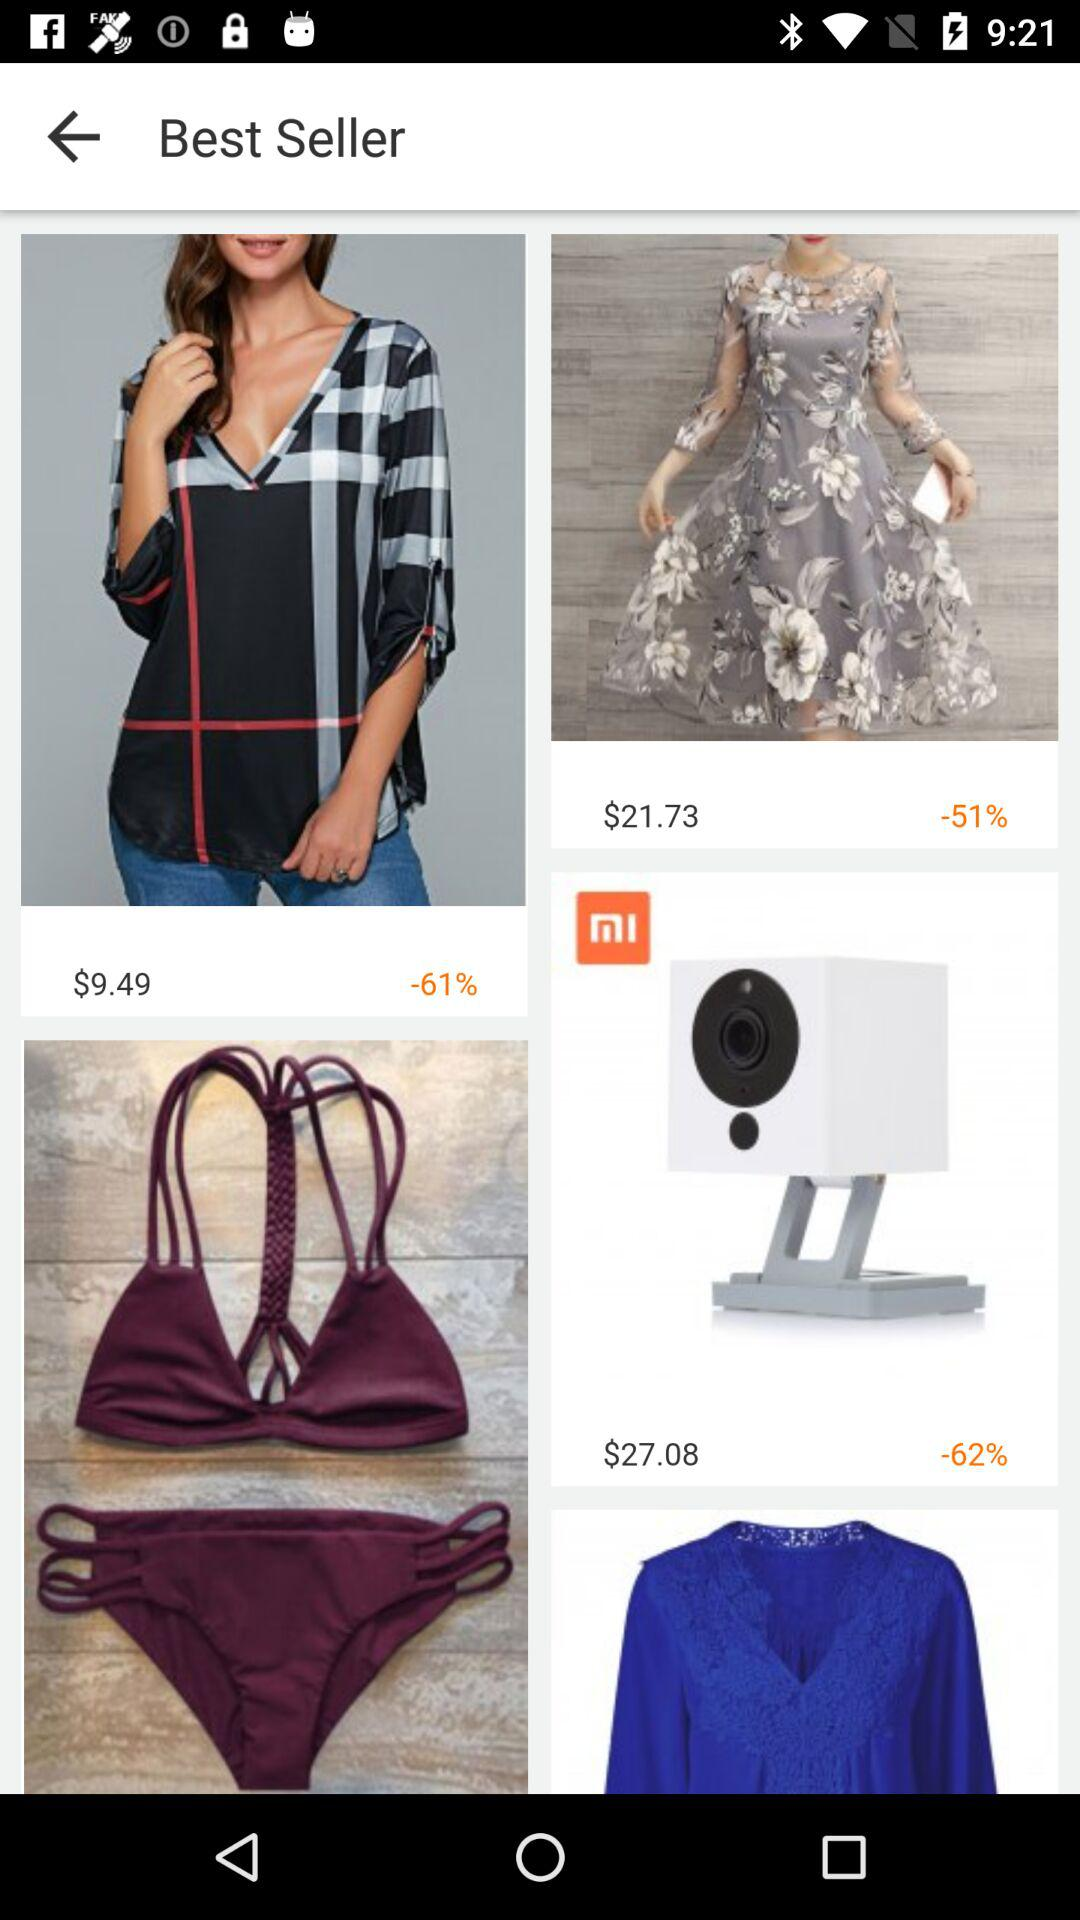What is the percentage discount on the dress? The discount is -51%. 